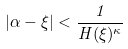<formula> <loc_0><loc_0><loc_500><loc_500>| \alpha - \xi | < \frac { 1 } { H ( \xi ) ^ { \kappa } }</formula> 